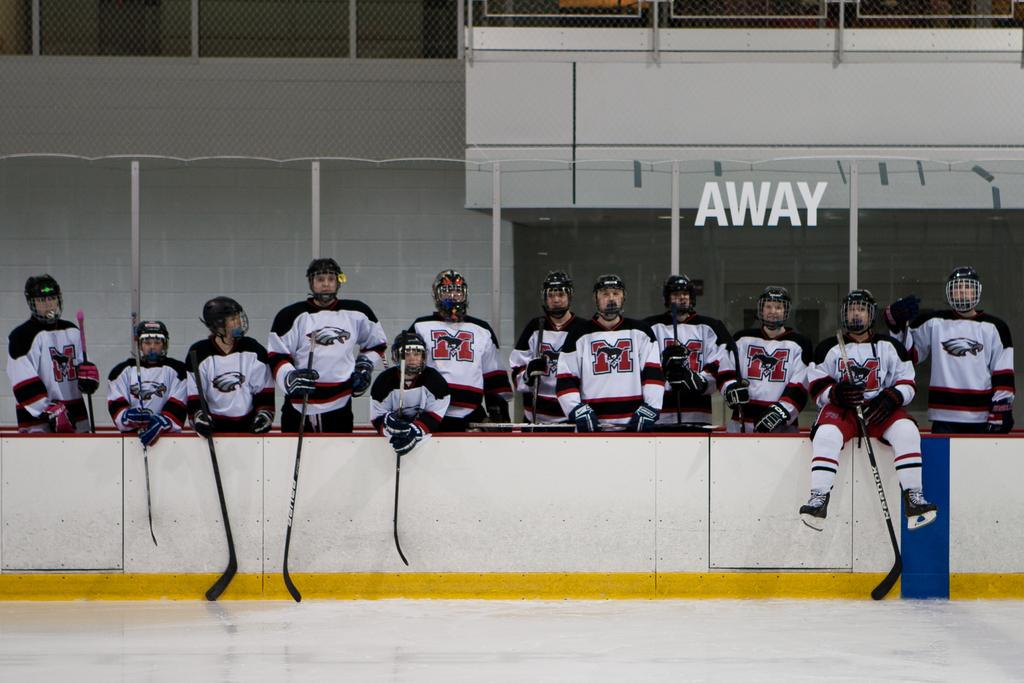<image>
Describe the image concisely. A number of hockey players gathered in front of a wall of ice that says Away on it. 